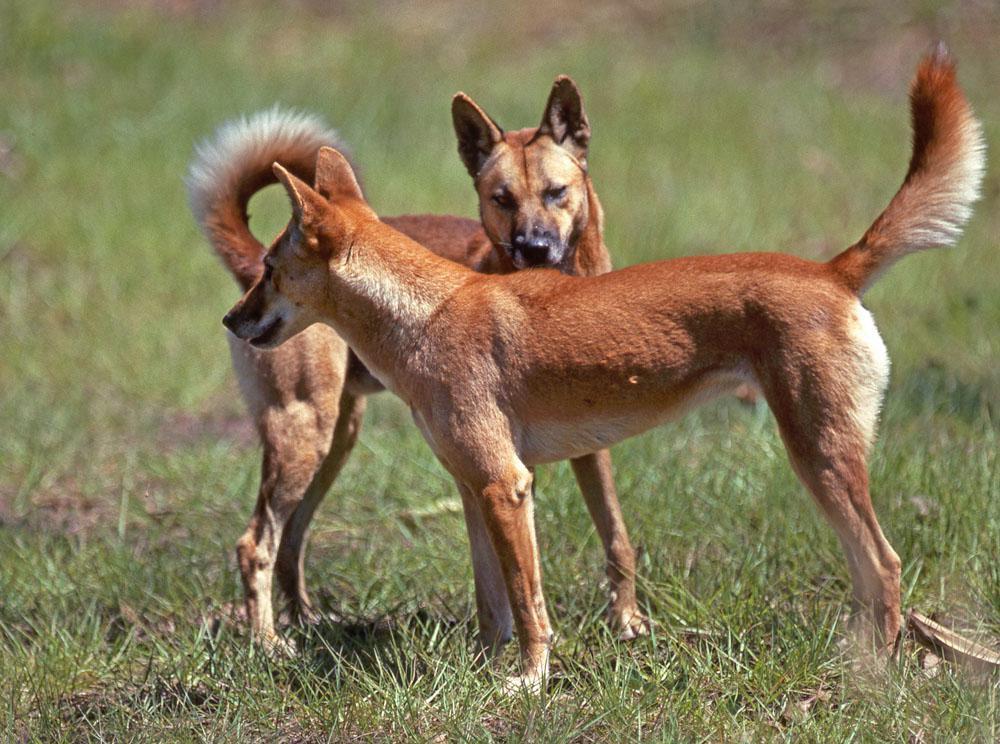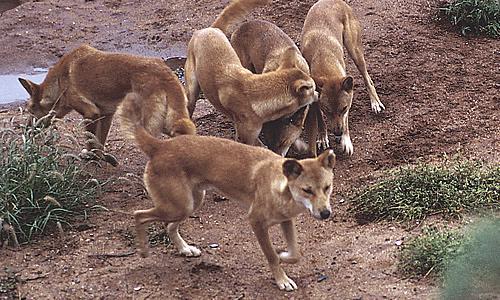The first image is the image on the left, the second image is the image on the right. Considering the images on both sides, is "The right image features a single dog posed outdoors facing forwards." valid? Answer yes or no. No. 